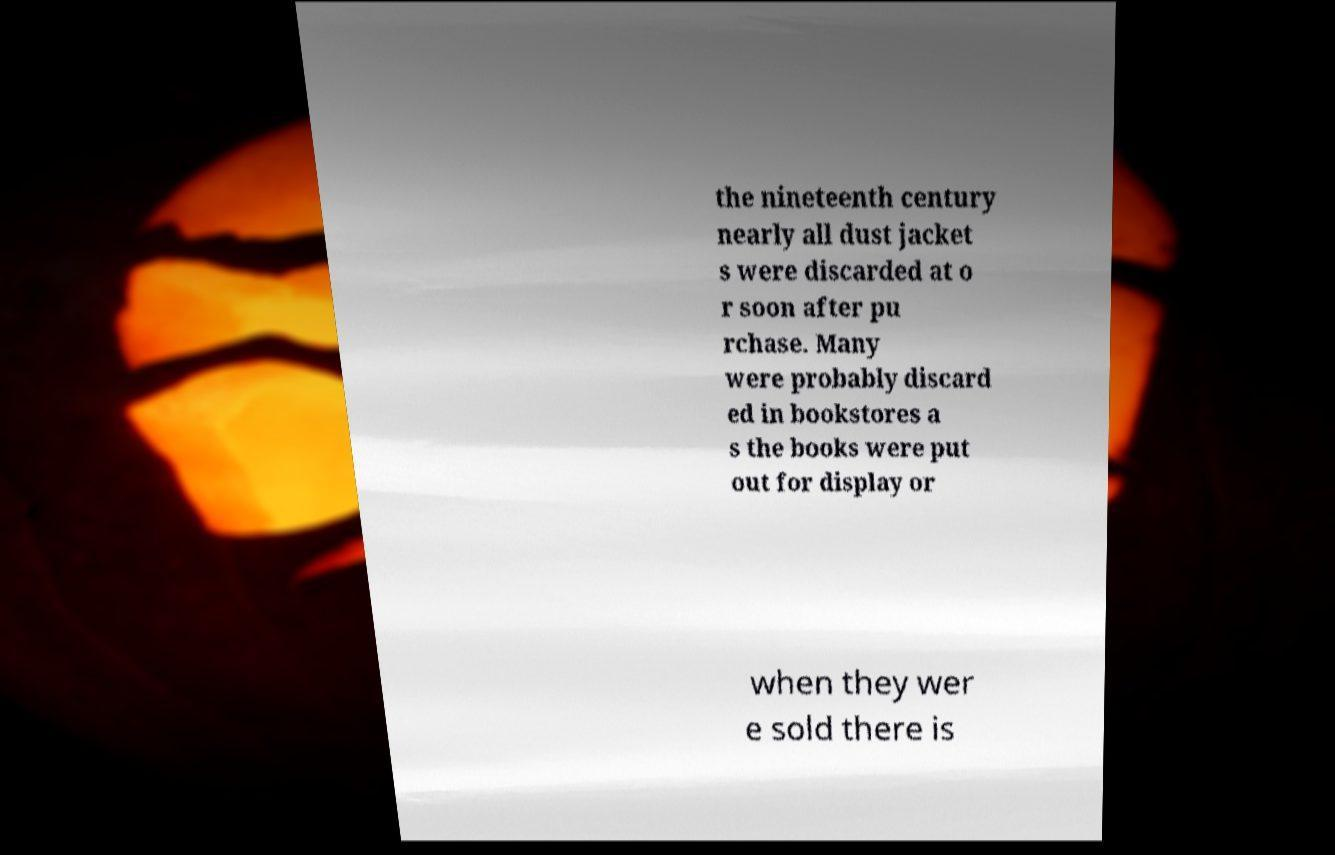Please read and relay the text visible in this image. What does it say? the nineteenth century nearly all dust jacket s were discarded at o r soon after pu rchase. Many were probably discard ed in bookstores a s the books were put out for display or when they wer e sold there is 